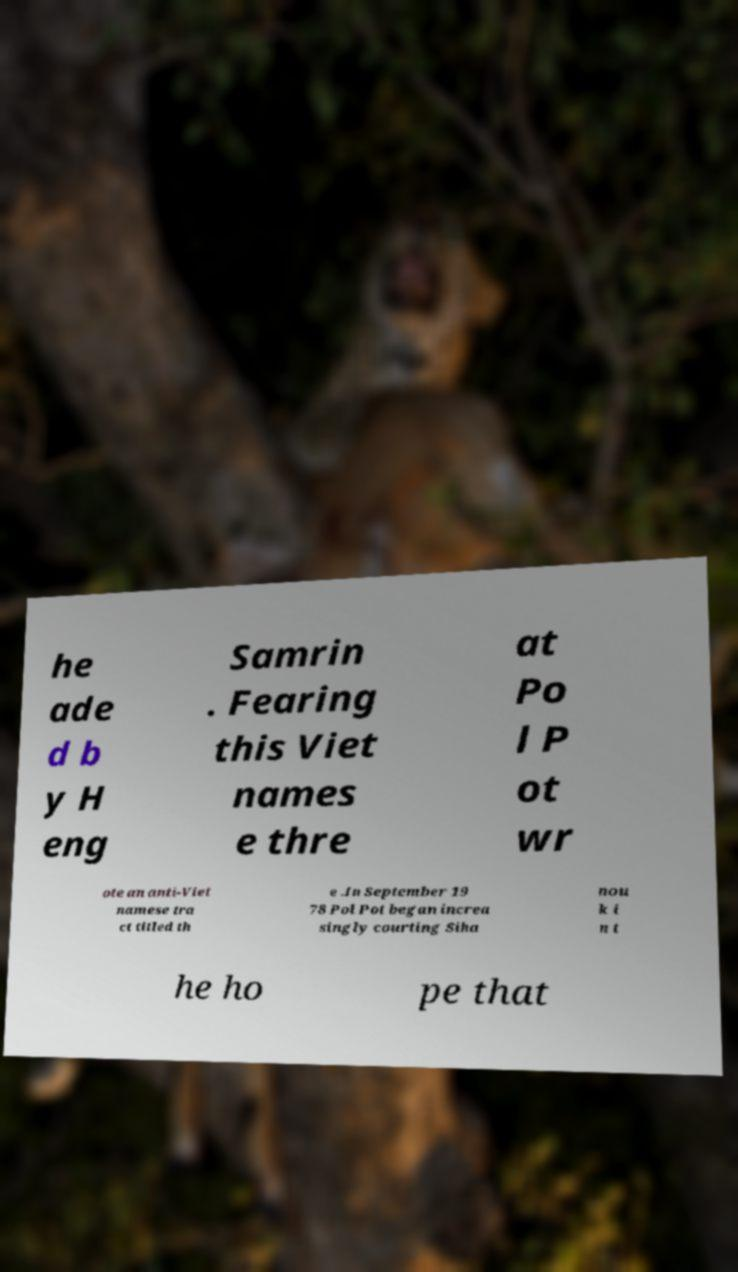Please identify and transcribe the text found in this image. he ade d b y H eng Samrin . Fearing this Viet names e thre at Po l P ot wr ote an anti-Viet namese tra ct titled th e .In September 19 78 Pol Pot began increa singly courting Siha nou k i n t he ho pe that 